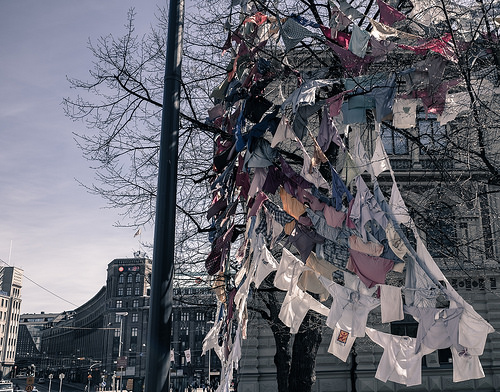<image>
Can you confirm if the shirt is in the tree? Yes. The shirt is contained within or inside the tree, showing a containment relationship. 